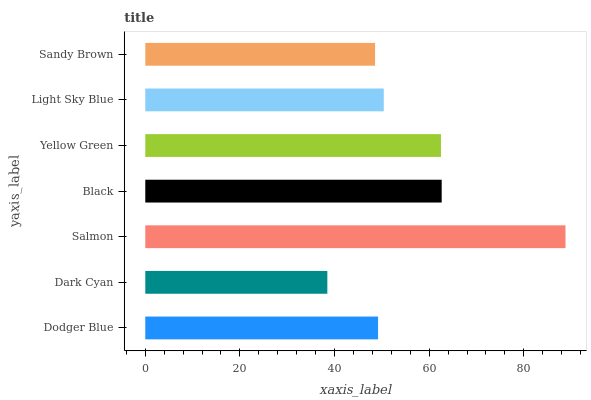Is Dark Cyan the minimum?
Answer yes or no. Yes. Is Salmon the maximum?
Answer yes or no. Yes. Is Salmon the minimum?
Answer yes or no. No. Is Dark Cyan the maximum?
Answer yes or no. No. Is Salmon greater than Dark Cyan?
Answer yes or no. Yes. Is Dark Cyan less than Salmon?
Answer yes or no. Yes. Is Dark Cyan greater than Salmon?
Answer yes or no. No. Is Salmon less than Dark Cyan?
Answer yes or no. No. Is Light Sky Blue the high median?
Answer yes or no. Yes. Is Light Sky Blue the low median?
Answer yes or no. Yes. Is Sandy Brown the high median?
Answer yes or no. No. Is Sandy Brown the low median?
Answer yes or no. No. 